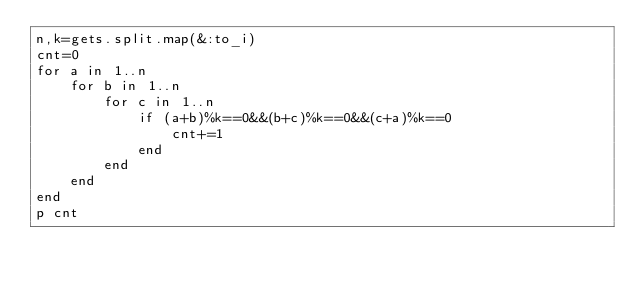Convert code to text. <code><loc_0><loc_0><loc_500><loc_500><_Ruby_>n,k=gets.split.map(&:to_i)
cnt=0
for a in 1..n
    for b in 1..n
        for c in 1..n
            if (a+b)%k==0&&(b+c)%k==0&&(c+a)%k==0
                cnt+=1
            end
        end
    end
end
p cnt
</code> 